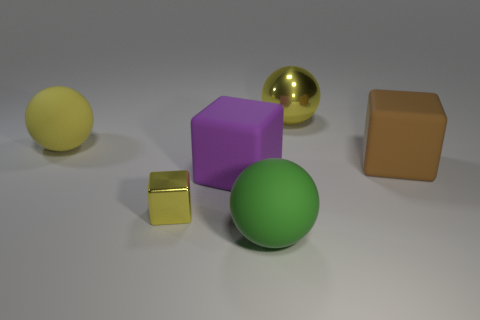Do the green ball and the small thing have the same material?
Offer a very short reply. No. Is there a purple block that is in front of the metallic object to the left of the large ball behind the yellow matte ball?
Your answer should be compact. No. How many other objects are the same shape as the big brown matte thing?
Your answer should be compact. 2. What shape is the thing that is both behind the big brown matte thing and in front of the large yellow metal object?
Your response must be concise. Sphere. There is a metallic thing behind the big rubber block that is to the right of the metallic thing to the right of the green rubber object; what color is it?
Provide a succinct answer. Yellow. Is the number of big rubber blocks that are in front of the brown matte block greater than the number of blocks that are on the left side of the big green matte sphere?
Give a very brief answer. No. What number of other objects are there of the same size as the metal ball?
Make the answer very short. 4. The rubber thing that is the same color as the big shiny sphere is what size?
Give a very brief answer. Large. There is a large yellow thing that is on the left side of the big green ball that is in front of the tiny yellow cube; what is it made of?
Your response must be concise. Rubber. Are there any yellow metallic spheres in front of the brown block?
Your response must be concise. No. 